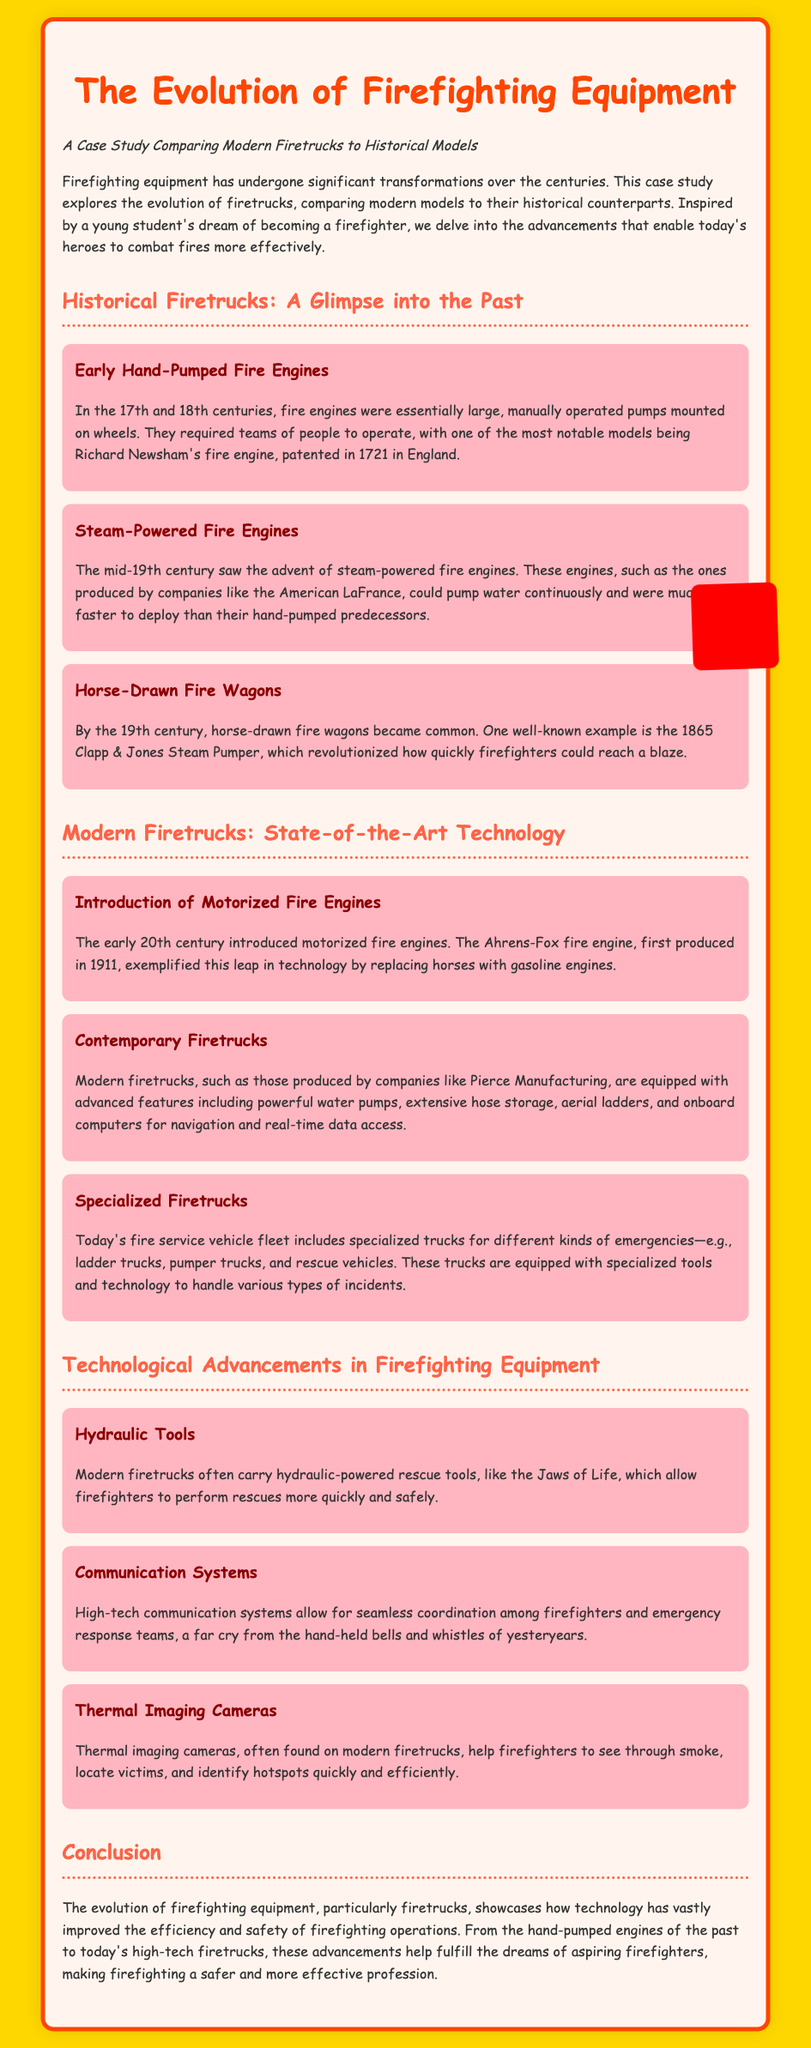What was the significant fire engine patented in 1721? Richard Newsham's fire engine is mentioned as a notable model patented in 1721 in England.
Answer: Richard Newsham's fire engine When did steam-powered fire engines become popular? The document states that steam-powered fire engines were introduced in the mid-19th century.
Answer: Mid-19th century What major innovation did the Ahrens-Fox fire engine represent? The Ahrens-Fox fire engine replaced horses with gasoline engines when first produced in 1911.
Answer: Gasoline engines What is one type of specialized firetruck mentioned? The document includes ladder trucks as a type of specialized firetruck designed for different kinds of emergencies.
Answer: Ladder trucks Which hydraulic tool is commonly found on modern firetrucks? The document mentions the Jaws of Life as a hydraulic-powered rescue tool found on modern firetrucks.
Answer: Jaws of Life What specific advancement helps firefighters locate victims in smoke? Thermal imaging cameras are highlighted as technology that assists firefighters in locating victims and identifying hotspots.
Answer: Thermal imaging cameras What was the main goal of the evolution of firefighting equipment? The document concludes that advancements help fulfill the dreams of aspiring firefighters and improve safety and efficiency.
Answer: Improve safety and efficiency What are the early fire engines described as? Early fire engines were described as large, manually operated pumps mounted on wheels.
Answer: Manually operated pumps Which company produced steam-powered fire engines in the mid-19th century? The document references the American LaFrance as a producer of steam-powered fire engines during that time.
Answer: American LaFrance 